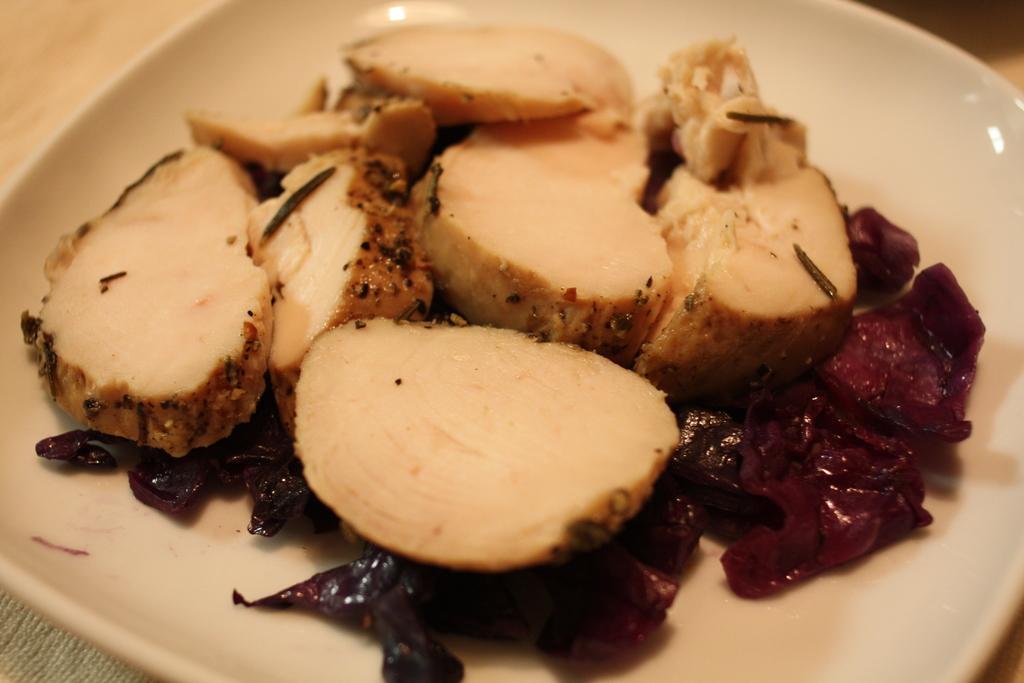In one or two sentences, can you explain what this image depicts? In this image, we can see a food in the plate. 